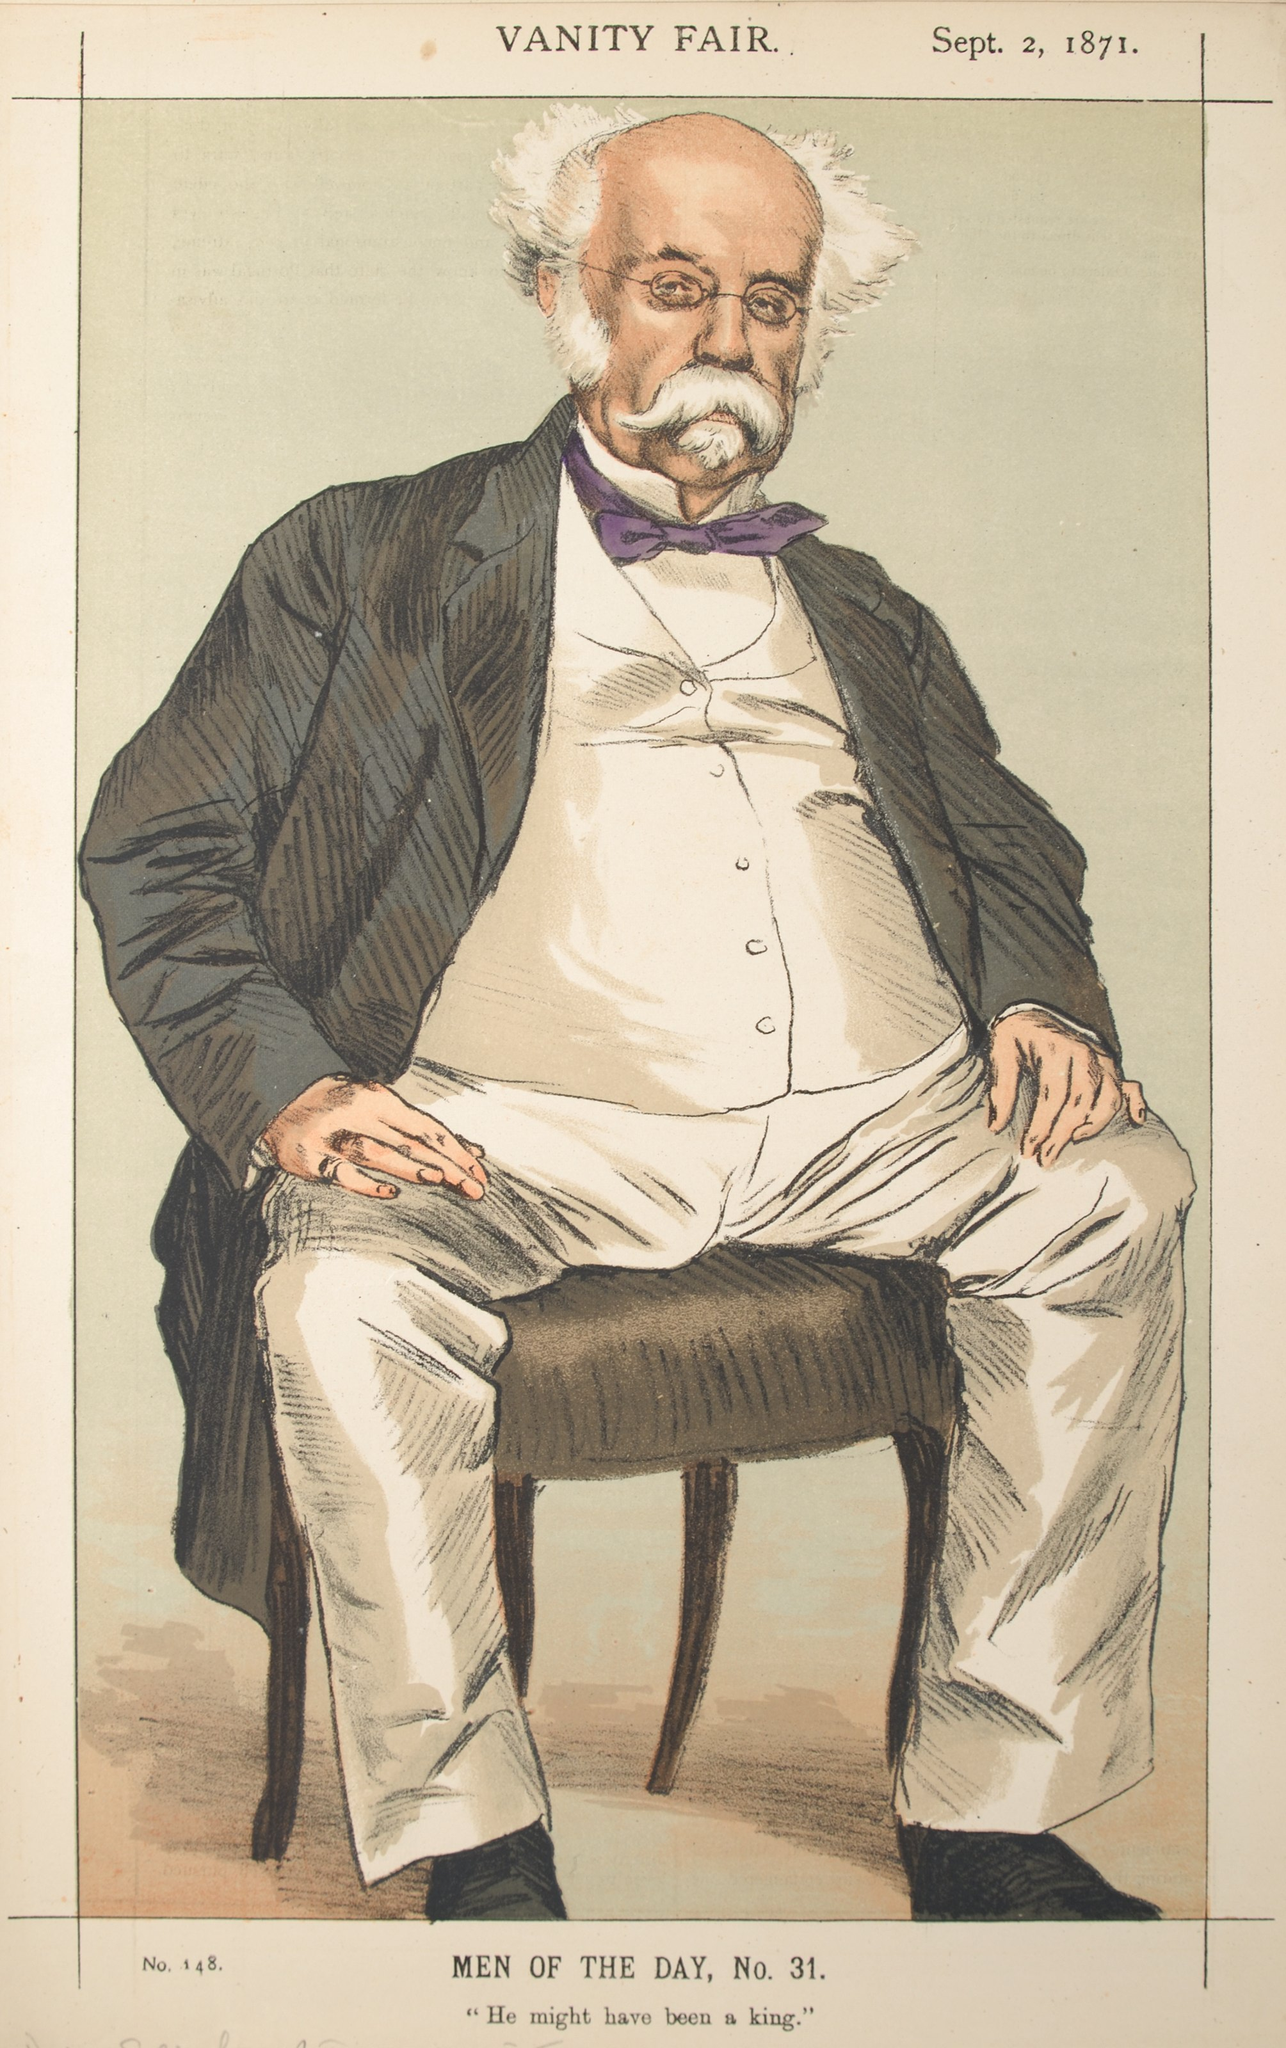If this image were part of a steampunk novel, what role would this man play? In a steampunk novel, this man could be envisioned as Dr. Reginald Cogsworth, a brilliant but slightly eccentric inventor. Known for his monocle that doubles as a multi-functional tool and his impeccable yet vintage style, Dr. Cogsworth is the mastermind behind many of the city's technological marvels. He is depicted sitting in his study, pondering his next great invention—a steam-powered apparatus that could revolutionize air travel. Despite his genius, he's humorously oblivious to the fact that his assistant, young Amelia, is often the one who brings his wild ideas to practical fruition. What might be a casual conversation in this steampunk world involving Dr. Reginald Cogsworth? Human: 'Dr. Cogsworth, have you seen the new steam-powered velocipede the Baron is riding?'
GPT: 'Ah, yes, quite the spectacle, isn't it? Though, frankly, I'm working on something far more sustainable and efficient. Just wait until you see my latest prototype—an airborne carriage powered by aetherium crystals!' 